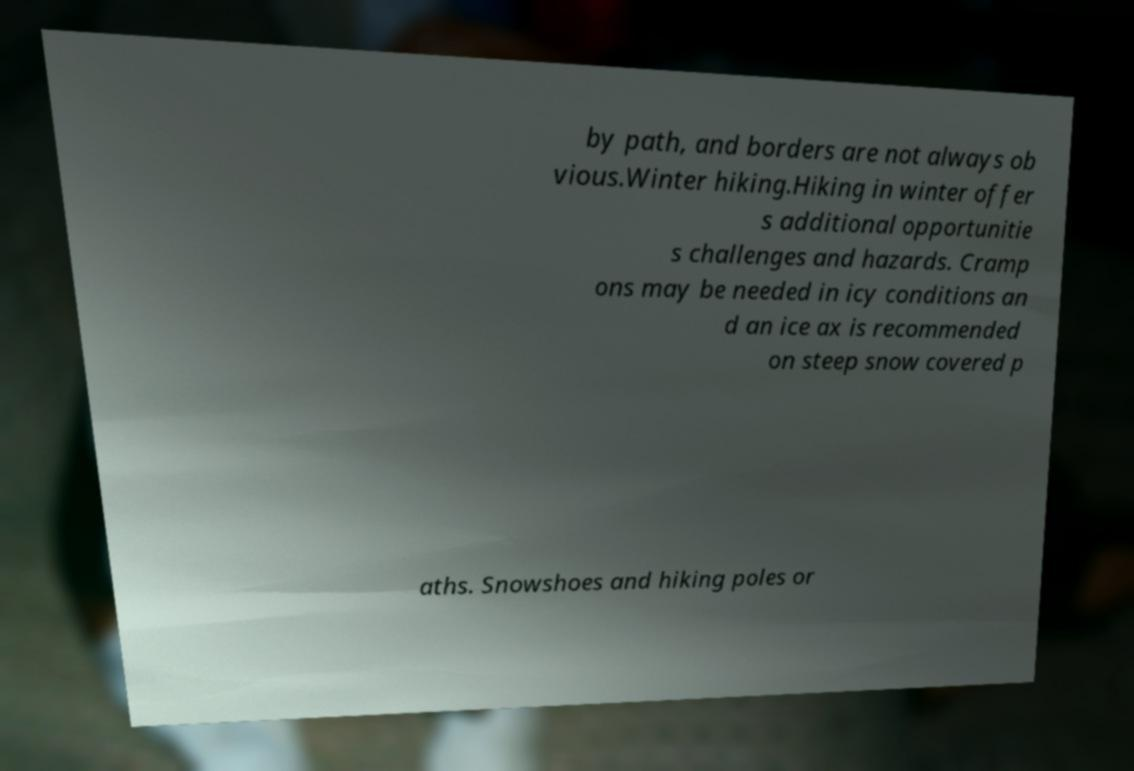There's text embedded in this image that I need extracted. Can you transcribe it verbatim? by path, and borders are not always ob vious.Winter hiking.Hiking in winter offer s additional opportunitie s challenges and hazards. Cramp ons may be needed in icy conditions an d an ice ax is recommended on steep snow covered p aths. Snowshoes and hiking poles or 